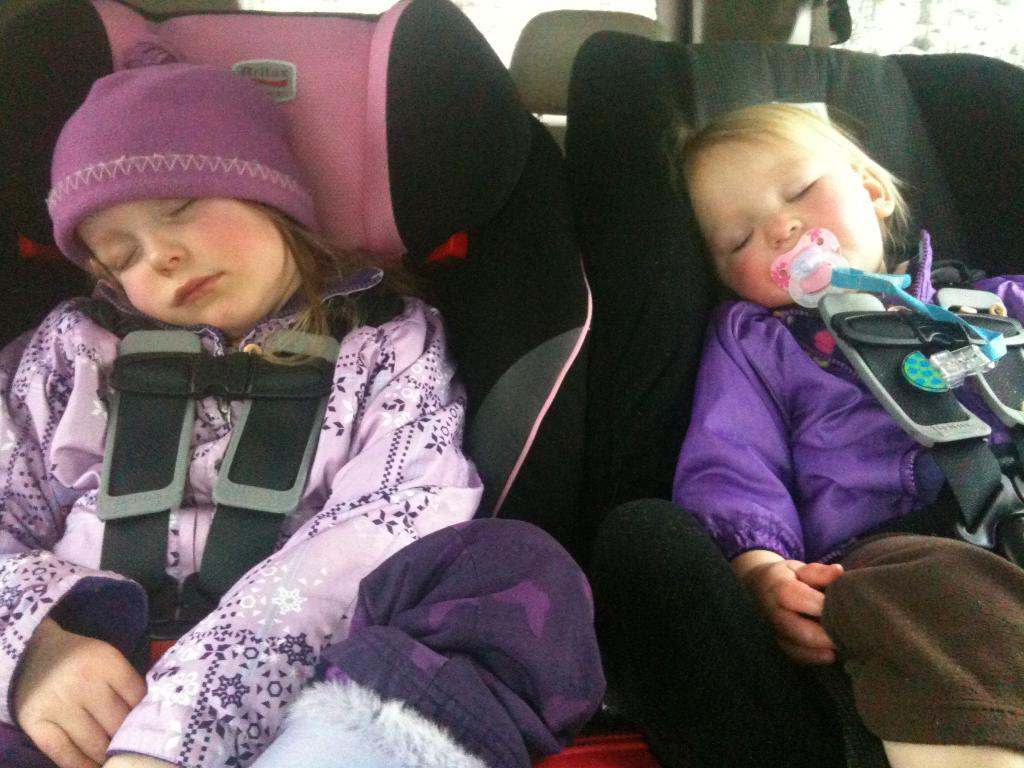How many people are in the image? There are two persons in the image. What are the persons in the image doing? Both persons are sleeping. Can you describe the clothing of the person on the right? The person on the right is wearing a purple and brown color dress. How about the clothing of the person on the left? The person on the left is wearing a purple color dress. What type of government is depicted in the image? There is no depiction of a government in the image; it features two people sleeping. Can you describe the cave in the image? There is no cave present in the image. 